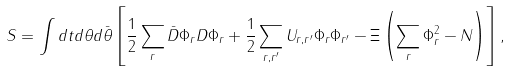Convert formula to latex. <formula><loc_0><loc_0><loc_500><loc_500>S = \int d t d \theta d \bar { \theta } \left [ \frac { 1 } { 2 } \sum _ { r } \bar { D } \Phi _ { r } D \Phi _ { r } + \frac { 1 } { 2 } \sum _ { { r } , { r } ^ { \prime } } U _ { { r } , { r } ^ { \prime } } \Phi _ { r } \Phi _ { { r } ^ { \prime } } - \Xi \left ( \sum _ { r } \Phi _ { r } ^ { 2 } - N \right ) \right ] ,</formula> 